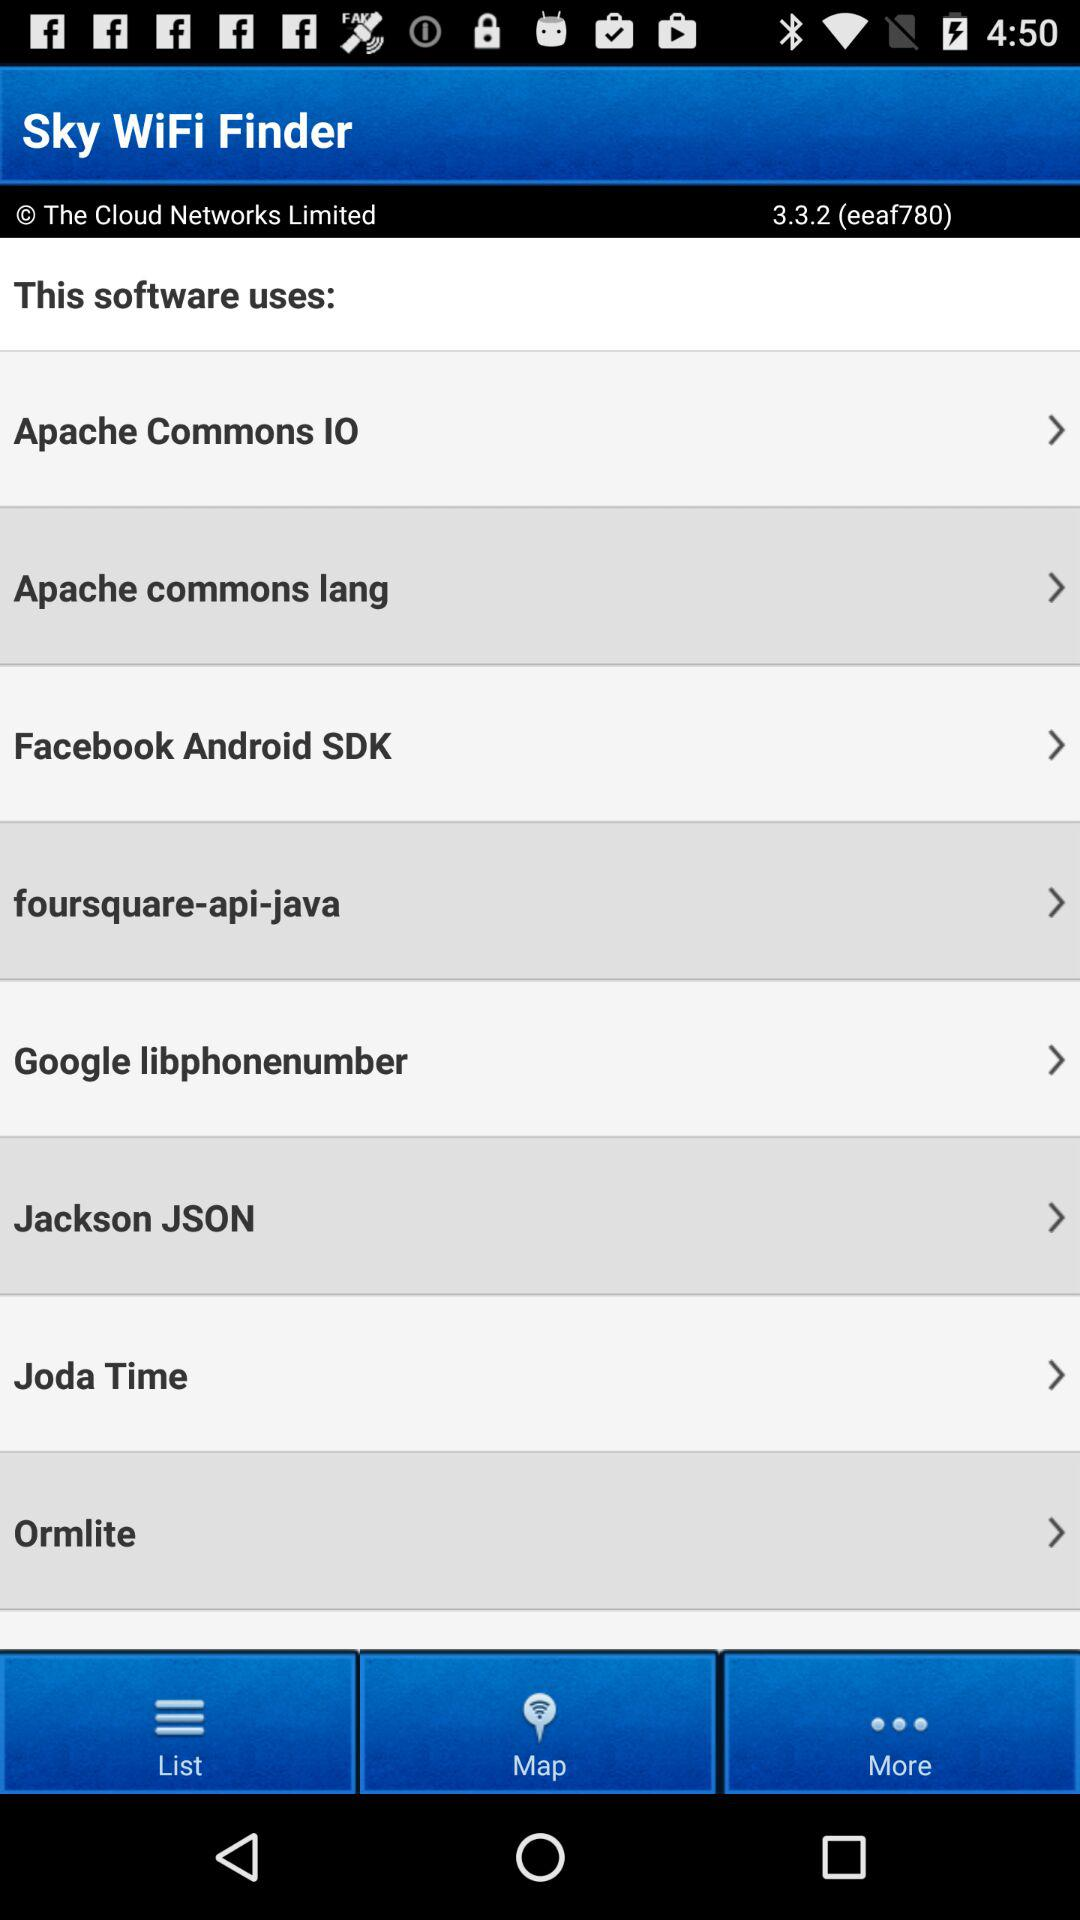What is the version of the app? The version of the app is 3.3.2 (eeaf780). 